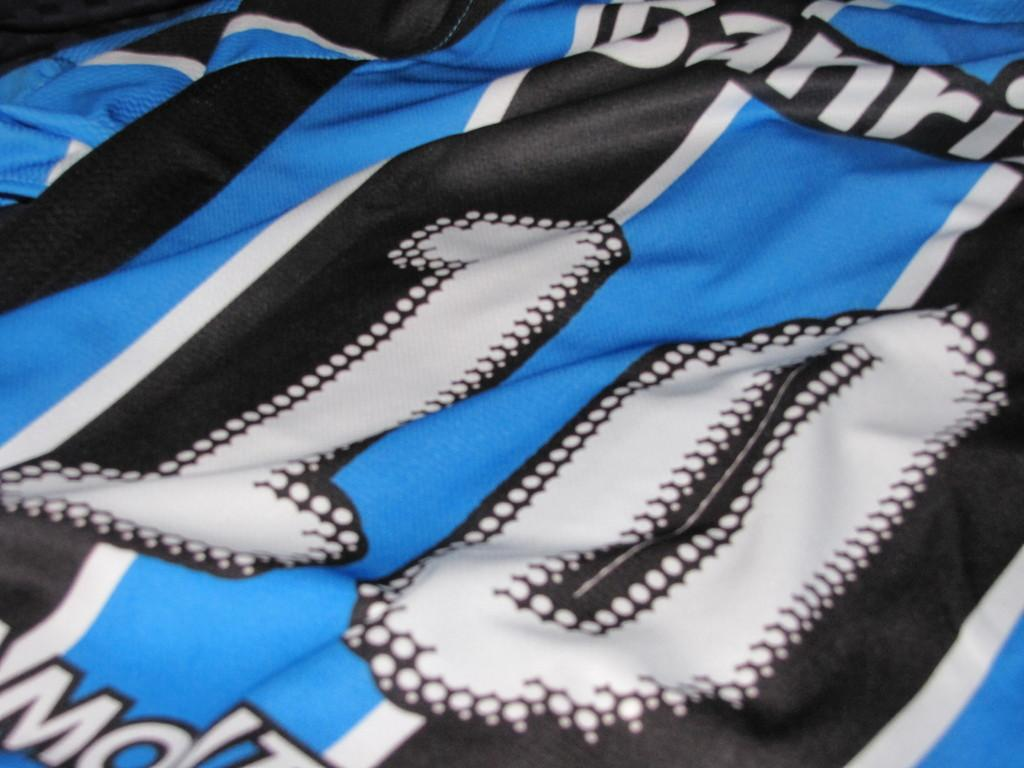Provide a one-sentence caption for the provided image. A blue, white and black sports jersey with the number 10 in white and outlined in black. 